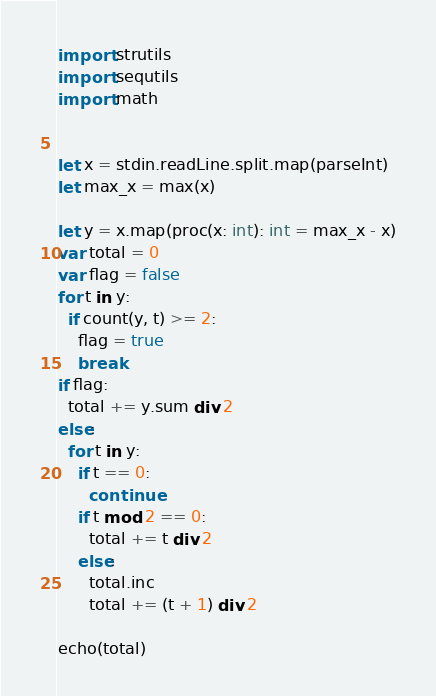Convert code to text. <code><loc_0><loc_0><loc_500><loc_500><_Nim_>import strutils
import sequtils
import math


let x = stdin.readLine.split.map(parseInt)
let max_x = max(x)

let y = x.map(proc(x: int): int = max_x - x)
var total = 0
var flag = false
for t in y:
  if count(y, t) >= 2:
    flag = true
    break
if flag:
  total += y.sum div 2
else:
  for t in y:
    if t == 0:
      continue
    if t mod 2 == 0:
      total += t div 2
    else:
      total.inc
      total += (t + 1) div 2

echo(total)
</code> 